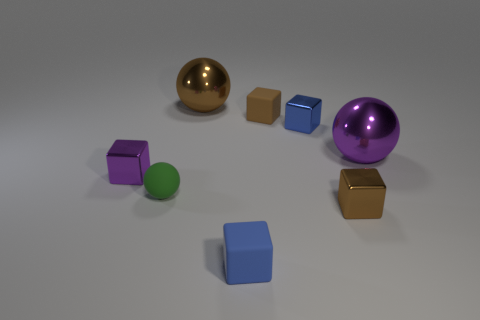How many small objects are blue things or cylinders? In the image, there are a total of two small objects that are either blue or cylindrical in shape; one is a blue cube and one is a green cylinder. 